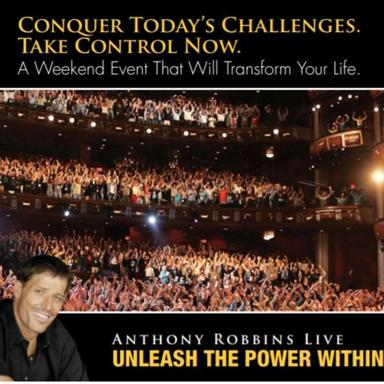Why does the image focus on the audience's reaction? The image emphasizes the audience's enthusiastic reaction to underscore the event's high impact and communal experience. It visually expresses the transformative energy and connection that participants share, highlighting the emotional uplift they experience through Tony Robbins' guidance. 